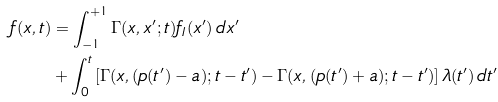Convert formula to latex. <formula><loc_0><loc_0><loc_500><loc_500>f ( x , t ) & = \int _ { - 1 } ^ { + 1 } \Gamma ( x , x ^ { \prime } ; t ) f _ { I } ( x ^ { \prime } ) \, d x ^ { \prime } \\ & + \int _ { 0 } ^ { t } \left [ \Gamma ( x , ( p ( t ^ { \prime } ) - a ) ; t - t ^ { \prime } ) - \Gamma ( x , ( p ( t ^ { \prime } ) + a ) ; t - t ^ { \prime } ) \right ] \lambda ( t ^ { \prime } ) \, d t ^ { \prime }</formula> 